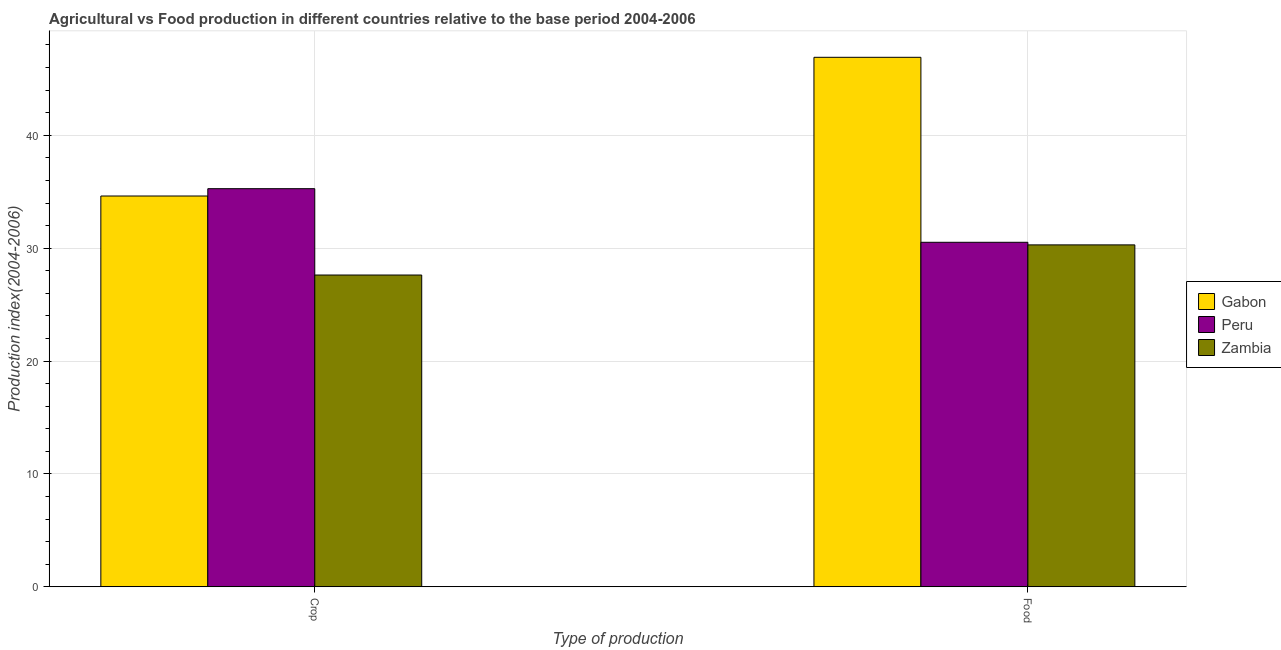How many different coloured bars are there?
Keep it short and to the point. 3. How many groups of bars are there?
Make the answer very short. 2. Are the number of bars per tick equal to the number of legend labels?
Your response must be concise. Yes. How many bars are there on the 1st tick from the left?
Offer a terse response. 3. What is the label of the 2nd group of bars from the left?
Your response must be concise. Food. What is the crop production index in Peru?
Offer a very short reply. 35.27. Across all countries, what is the maximum crop production index?
Keep it short and to the point. 35.27. Across all countries, what is the minimum food production index?
Your response must be concise. 30.29. In which country was the crop production index maximum?
Provide a succinct answer. Peru. In which country was the food production index minimum?
Provide a short and direct response. Zambia. What is the total food production index in the graph?
Ensure brevity in your answer.  107.72. What is the difference between the crop production index in Zambia and that in Peru?
Your answer should be compact. -7.65. What is the difference between the food production index in Peru and the crop production index in Zambia?
Your answer should be compact. 2.9. What is the average crop production index per country?
Provide a succinct answer. 32.5. What is the difference between the crop production index and food production index in Peru?
Provide a succinct answer. 4.75. In how many countries, is the crop production index greater than 32 ?
Provide a short and direct response. 2. What is the ratio of the food production index in Zambia to that in Gabon?
Your response must be concise. 0.65. Is the crop production index in Zambia less than that in Peru?
Provide a succinct answer. Yes. What does the 3rd bar from the left in Crop represents?
Give a very brief answer. Zambia. What does the 1st bar from the right in Crop represents?
Your response must be concise. Zambia. Are all the bars in the graph horizontal?
Offer a terse response. No. What is the difference between two consecutive major ticks on the Y-axis?
Your response must be concise. 10. Where does the legend appear in the graph?
Offer a terse response. Center right. How are the legend labels stacked?
Your answer should be very brief. Vertical. What is the title of the graph?
Provide a succinct answer. Agricultural vs Food production in different countries relative to the base period 2004-2006. What is the label or title of the X-axis?
Offer a terse response. Type of production. What is the label or title of the Y-axis?
Ensure brevity in your answer.  Production index(2004-2006). What is the Production index(2004-2006) of Gabon in Crop?
Make the answer very short. 34.62. What is the Production index(2004-2006) in Peru in Crop?
Provide a short and direct response. 35.27. What is the Production index(2004-2006) in Zambia in Crop?
Provide a short and direct response. 27.62. What is the Production index(2004-2006) of Gabon in Food?
Provide a short and direct response. 46.91. What is the Production index(2004-2006) in Peru in Food?
Your response must be concise. 30.52. What is the Production index(2004-2006) in Zambia in Food?
Ensure brevity in your answer.  30.29. Across all Type of production, what is the maximum Production index(2004-2006) in Gabon?
Your answer should be compact. 46.91. Across all Type of production, what is the maximum Production index(2004-2006) of Peru?
Your answer should be compact. 35.27. Across all Type of production, what is the maximum Production index(2004-2006) of Zambia?
Ensure brevity in your answer.  30.29. Across all Type of production, what is the minimum Production index(2004-2006) in Gabon?
Keep it short and to the point. 34.62. Across all Type of production, what is the minimum Production index(2004-2006) of Peru?
Your answer should be very brief. 30.52. Across all Type of production, what is the minimum Production index(2004-2006) of Zambia?
Your response must be concise. 27.62. What is the total Production index(2004-2006) in Gabon in the graph?
Give a very brief answer. 81.53. What is the total Production index(2004-2006) in Peru in the graph?
Give a very brief answer. 65.79. What is the total Production index(2004-2006) in Zambia in the graph?
Make the answer very short. 57.91. What is the difference between the Production index(2004-2006) in Gabon in Crop and that in Food?
Ensure brevity in your answer.  -12.29. What is the difference between the Production index(2004-2006) of Peru in Crop and that in Food?
Keep it short and to the point. 4.75. What is the difference between the Production index(2004-2006) in Zambia in Crop and that in Food?
Provide a short and direct response. -2.67. What is the difference between the Production index(2004-2006) of Gabon in Crop and the Production index(2004-2006) of Peru in Food?
Make the answer very short. 4.1. What is the difference between the Production index(2004-2006) of Gabon in Crop and the Production index(2004-2006) of Zambia in Food?
Your answer should be very brief. 4.33. What is the difference between the Production index(2004-2006) in Peru in Crop and the Production index(2004-2006) in Zambia in Food?
Offer a terse response. 4.98. What is the average Production index(2004-2006) in Gabon per Type of production?
Make the answer very short. 40.77. What is the average Production index(2004-2006) of Peru per Type of production?
Keep it short and to the point. 32.9. What is the average Production index(2004-2006) of Zambia per Type of production?
Your answer should be very brief. 28.95. What is the difference between the Production index(2004-2006) in Gabon and Production index(2004-2006) in Peru in Crop?
Provide a short and direct response. -0.65. What is the difference between the Production index(2004-2006) of Gabon and Production index(2004-2006) of Zambia in Crop?
Your response must be concise. 7. What is the difference between the Production index(2004-2006) in Peru and Production index(2004-2006) in Zambia in Crop?
Keep it short and to the point. 7.65. What is the difference between the Production index(2004-2006) of Gabon and Production index(2004-2006) of Peru in Food?
Give a very brief answer. 16.39. What is the difference between the Production index(2004-2006) in Gabon and Production index(2004-2006) in Zambia in Food?
Your answer should be very brief. 16.62. What is the difference between the Production index(2004-2006) in Peru and Production index(2004-2006) in Zambia in Food?
Ensure brevity in your answer.  0.23. What is the ratio of the Production index(2004-2006) in Gabon in Crop to that in Food?
Your answer should be very brief. 0.74. What is the ratio of the Production index(2004-2006) of Peru in Crop to that in Food?
Give a very brief answer. 1.16. What is the ratio of the Production index(2004-2006) in Zambia in Crop to that in Food?
Ensure brevity in your answer.  0.91. What is the difference between the highest and the second highest Production index(2004-2006) in Gabon?
Ensure brevity in your answer.  12.29. What is the difference between the highest and the second highest Production index(2004-2006) in Peru?
Your answer should be compact. 4.75. What is the difference between the highest and the second highest Production index(2004-2006) in Zambia?
Provide a short and direct response. 2.67. What is the difference between the highest and the lowest Production index(2004-2006) in Gabon?
Offer a very short reply. 12.29. What is the difference between the highest and the lowest Production index(2004-2006) of Peru?
Your response must be concise. 4.75. What is the difference between the highest and the lowest Production index(2004-2006) in Zambia?
Offer a terse response. 2.67. 